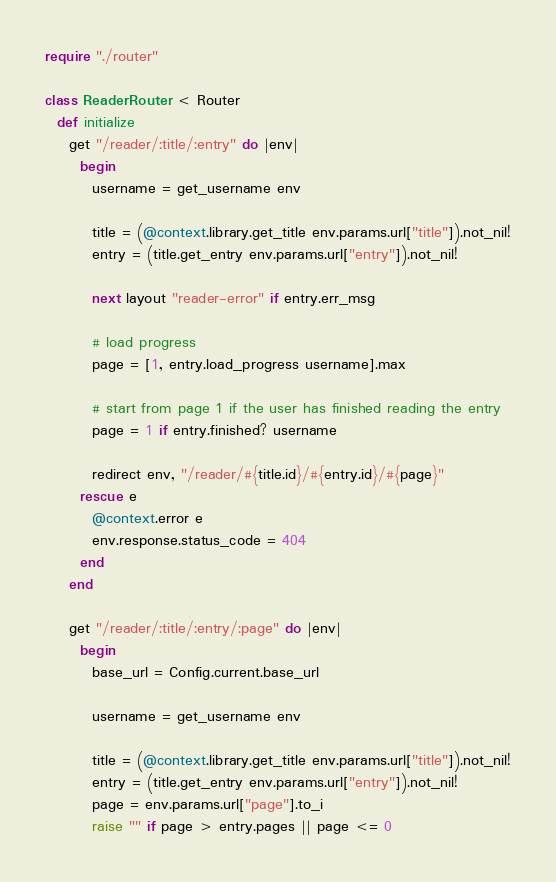<code> <loc_0><loc_0><loc_500><loc_500><_Crystal_>require "./router"

class ReaderRouter < Router
  def initialize
    get "/reader/:title/:entry" do |env|
      begin
        username = get_username env

        title = (@context.library.get_title env.params.url["title"]).not_nil!
        entry = (title.get_entry env.params.url["entry"]).not_nil!

        next layout "reader-error" if entry.err_msg

        # load progress
        page = [1, entry.load_progress username].max

        # start from page 1 if the user has finished reading the entry
        page = 1 if entry.finished? username

        redirect env, "/reader/#{title.id}/#{entry.id}/#{page}"
      rescue e
        @context.error e
        env.response.status_code = 404
      end
    end

    get "/reader/:title/:entry/:page" do |env|
      begin
        base_url = Config.current.base_url

        username = get_username env

        title = (@context.library.get_title env.params.url["title"]).not_nil!
        entry = (title.get_entry env.params.url["entry"]).not_nil!
        page = env.params.url["page"].to_i
        raise "" if page > entry.pages || page <= 0
</code> 